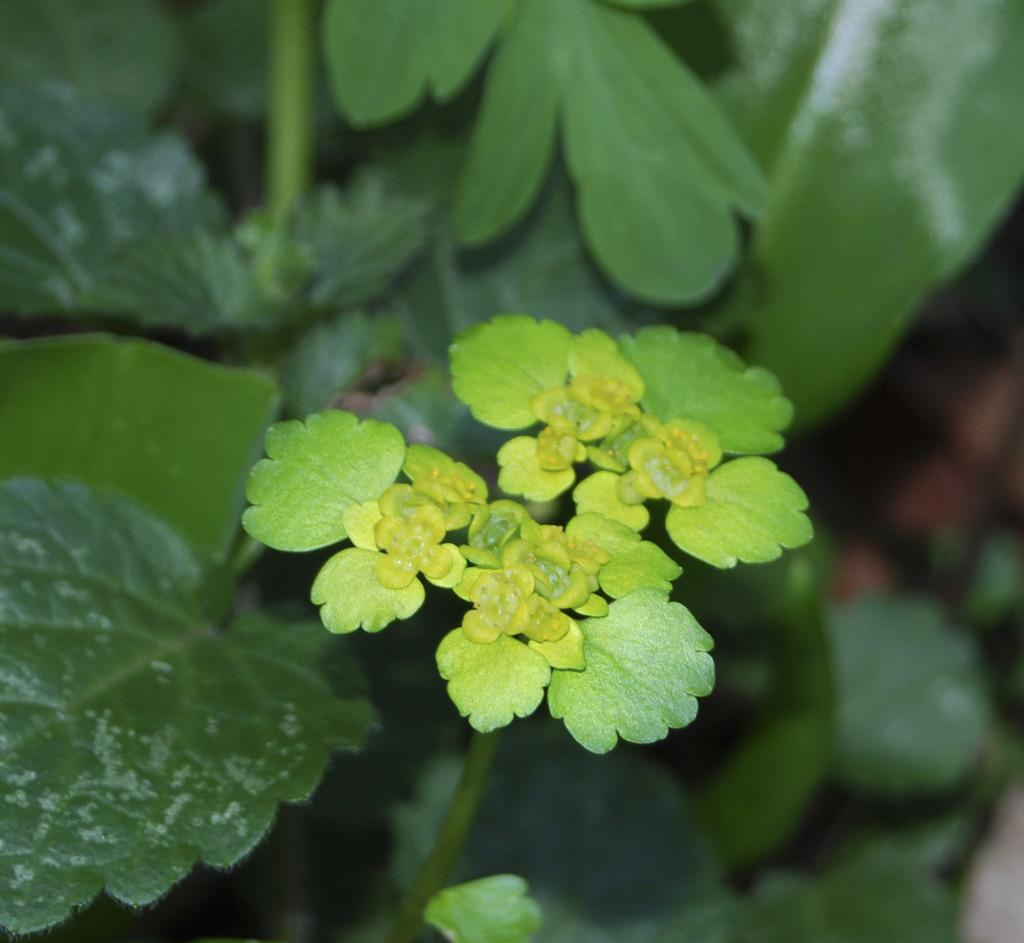What type of living organisms can be seen in the image? Plants can be seen in the image. What part of the plant is visible in the image? Many leaves are visible in the image. What type of worm can be seen crawling on the leaves in the image? There is no worm present in the image; only plants and leaves are visible. 